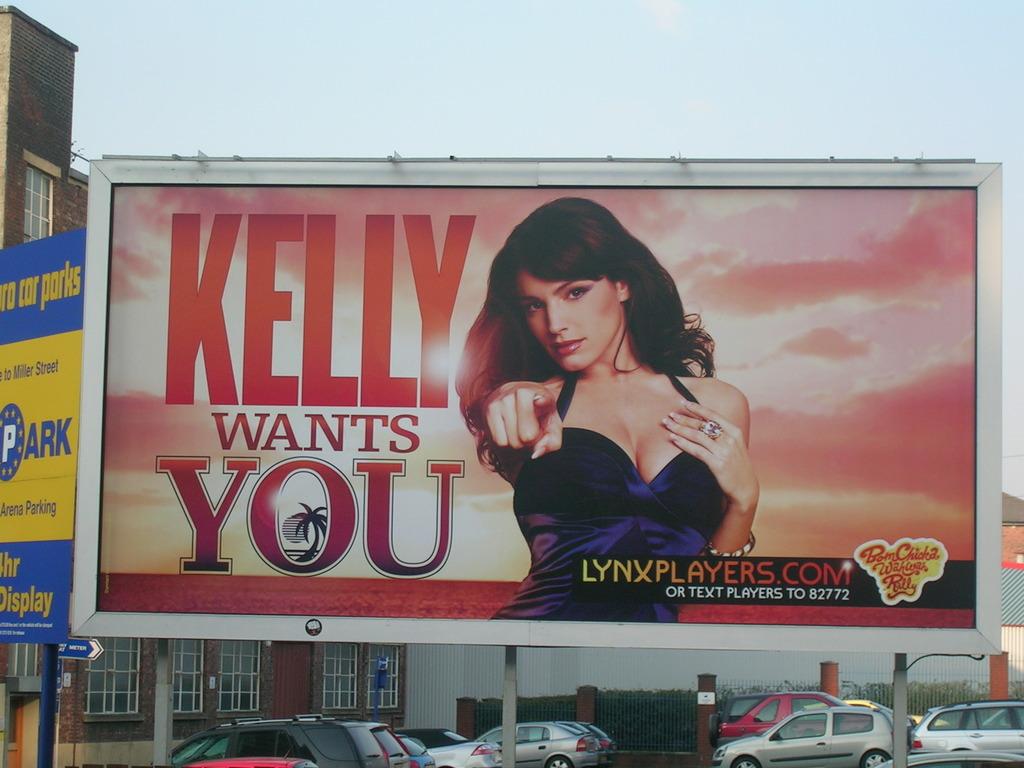What is this billboarding saying?
Offer a very short reply. Kelly wants you. Whats the name of the billboard?
Offer a very short reply. Kelly wants you. 